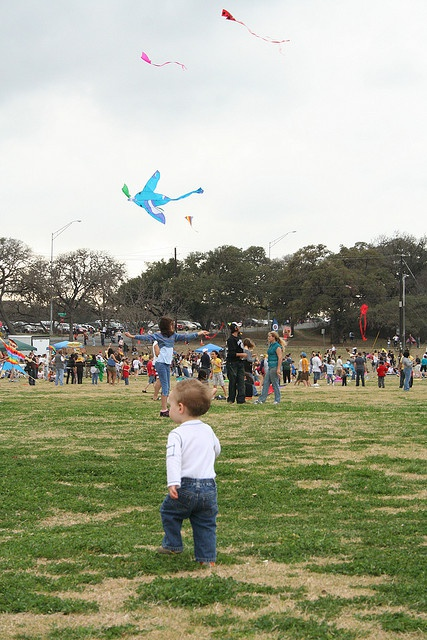Describe the objects in this image and their specific colors. I can see people in lightgray, black, gray, tan, and darkgray tones, people in lightgray, lavender, black, gray, and navy tones, people in lightgray, gray, black, and blue tones, people in lightgray, black, gray, and olive tones, and people in lightgray, gray, teal, and tan tones in this image. 